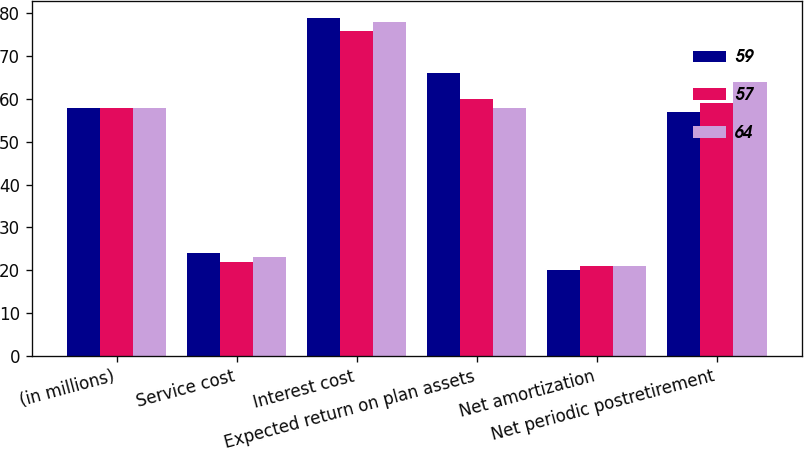Convert chart to OTSL. <chart><loc_0><loc_0><loc_500><loc_500><stacked_bar_chart><ecel><fcel>(in millions)<fcel>Service cost<fcel>Interest cost<fcel>Expected return on plan assets<fcel>Net amortization<fcel>Net periodic postretirement<nl><fcel>59<fcel>58<fcel>24<fcel>79<fcel>66<fcel>20<fcel>57<nl><fcel>57<fcel>58<fcel>22<fcel>76<fcel>60<fcel>21<fcel>59<nl><fcel>64<fcel>58<fcel>23<fcel>78<fcel>58<fcel>21<fcel>64<nl></chart> 